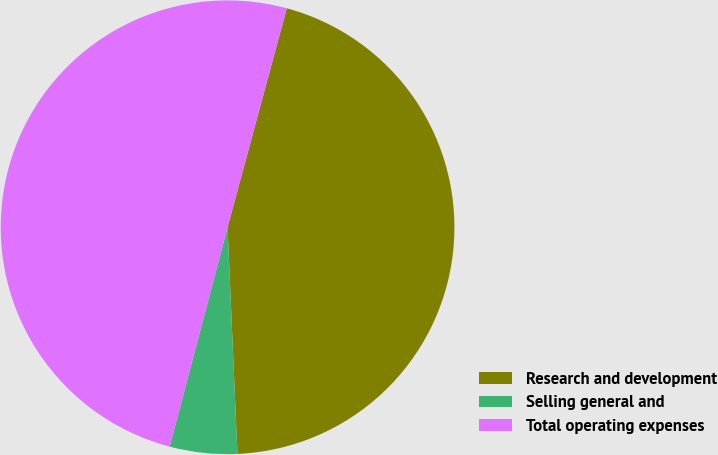<chart> <loc_0><loc_0><loc_500><loc_500><pie_chart><fcel>Research and development<fcel>Selling general and<fcel>Total operating expenses<nl><fcel>45.1%<fcel>4.8%<fcel>50.1%<nl></chart> 